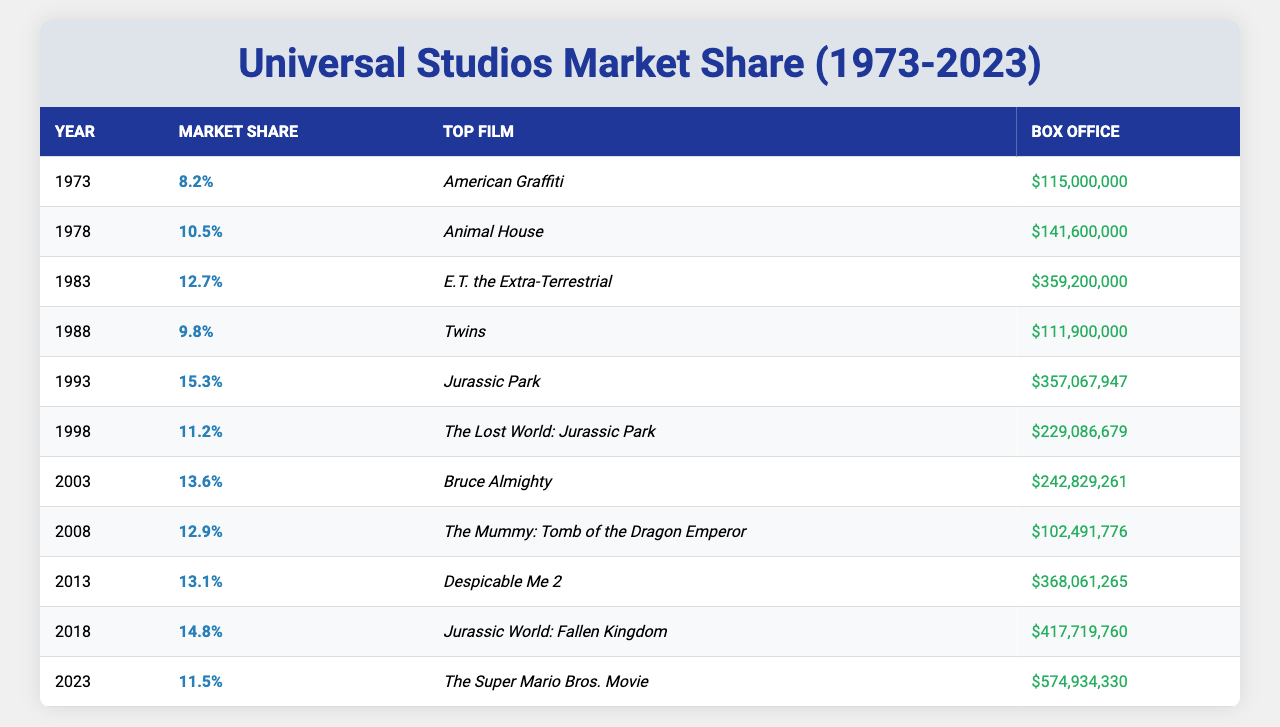What was the market share of Universal Studios in 1993? The table shows that in 1993, the market share was 15.3%.
Answer: 15.3% Which film had the highest box office earnings in 2018? According to the table, the highest box office earnings in 2018 was for "Jurassic World: Fallen Kingdom," which earned $417,719,760.
Answer: Jurassic World: Fallen Kingdom How many years had Universal Studios a market share of over 12% from 1973 to 2023? Looking at the table, the years with over 12% market share are 1983, 1993, 2003, 2013, and 2018. That totals to 5 years.
Answer: 5 years What is the percentage decrease in market share from 2018 to 2023? The market share in 2018 was 14.8% and in 2023 it was 11.5%. The decrease is 14.8% - 11.5% = 3.3%.
Answer: 3.3% Which year had the highest market share and what was the top film of that year? The highest market share was in 1993 with 15.3%, and the top film was "Jurassic Park."
Answer: 1993, Jurassic Park In which year did Universal Studios see a decrease in market share compared to the previous year? The years where the market share decreased compared to the previous year include 1988 (compared to 1983), 1998 (compared to 1993), 2008 (compared to 2003), and 2023 (compared to 2018).
Answer: 1988, 1998, 2008, 2023 Calculate the average market share of Universal Studios over the provided years. The market shares from the table are: 8.2, 10.5, 12.7, 9.8, 15.3, 11.2, 13.6, 12.9, 13.1, 14.8, and 11.5. The sum is 8.2 + 10.5 + 12.7 + 9.8 + 15.3 + 11.2 + 13.6 + 12.9 + 13.1 + 14.8 + 11.5 = 138.6. Dividing by the number of years (11), the average is 138.6 / 11 = 12.6.
Answer: 12.6 Which two years had the lowest market share? The years with the lowest market shares are 1973 with 8.2% and 1988 with 9.8%.
Answer: 1973, 1988 What was the box office for the top film in 2003, and how does it compare to the box office of the top film in 1998? The top film in 2003 was "Bruce Almighty" with a box office of $242,829,261, while in 1998, it was "The Lost World: Jurassic Park" with $229,086,679. The comparison shows that the box office in 2003 was higher by $13,742,582.
Answer: $242,829,261, higher by $13,742,582 Was the market share higher in 2008 or in 2013? The market share in 2008 was 12.9% and in 2013 it was 13.1%. Therefore, the market share was higher in 2013.
Answer: 2013 was higher 